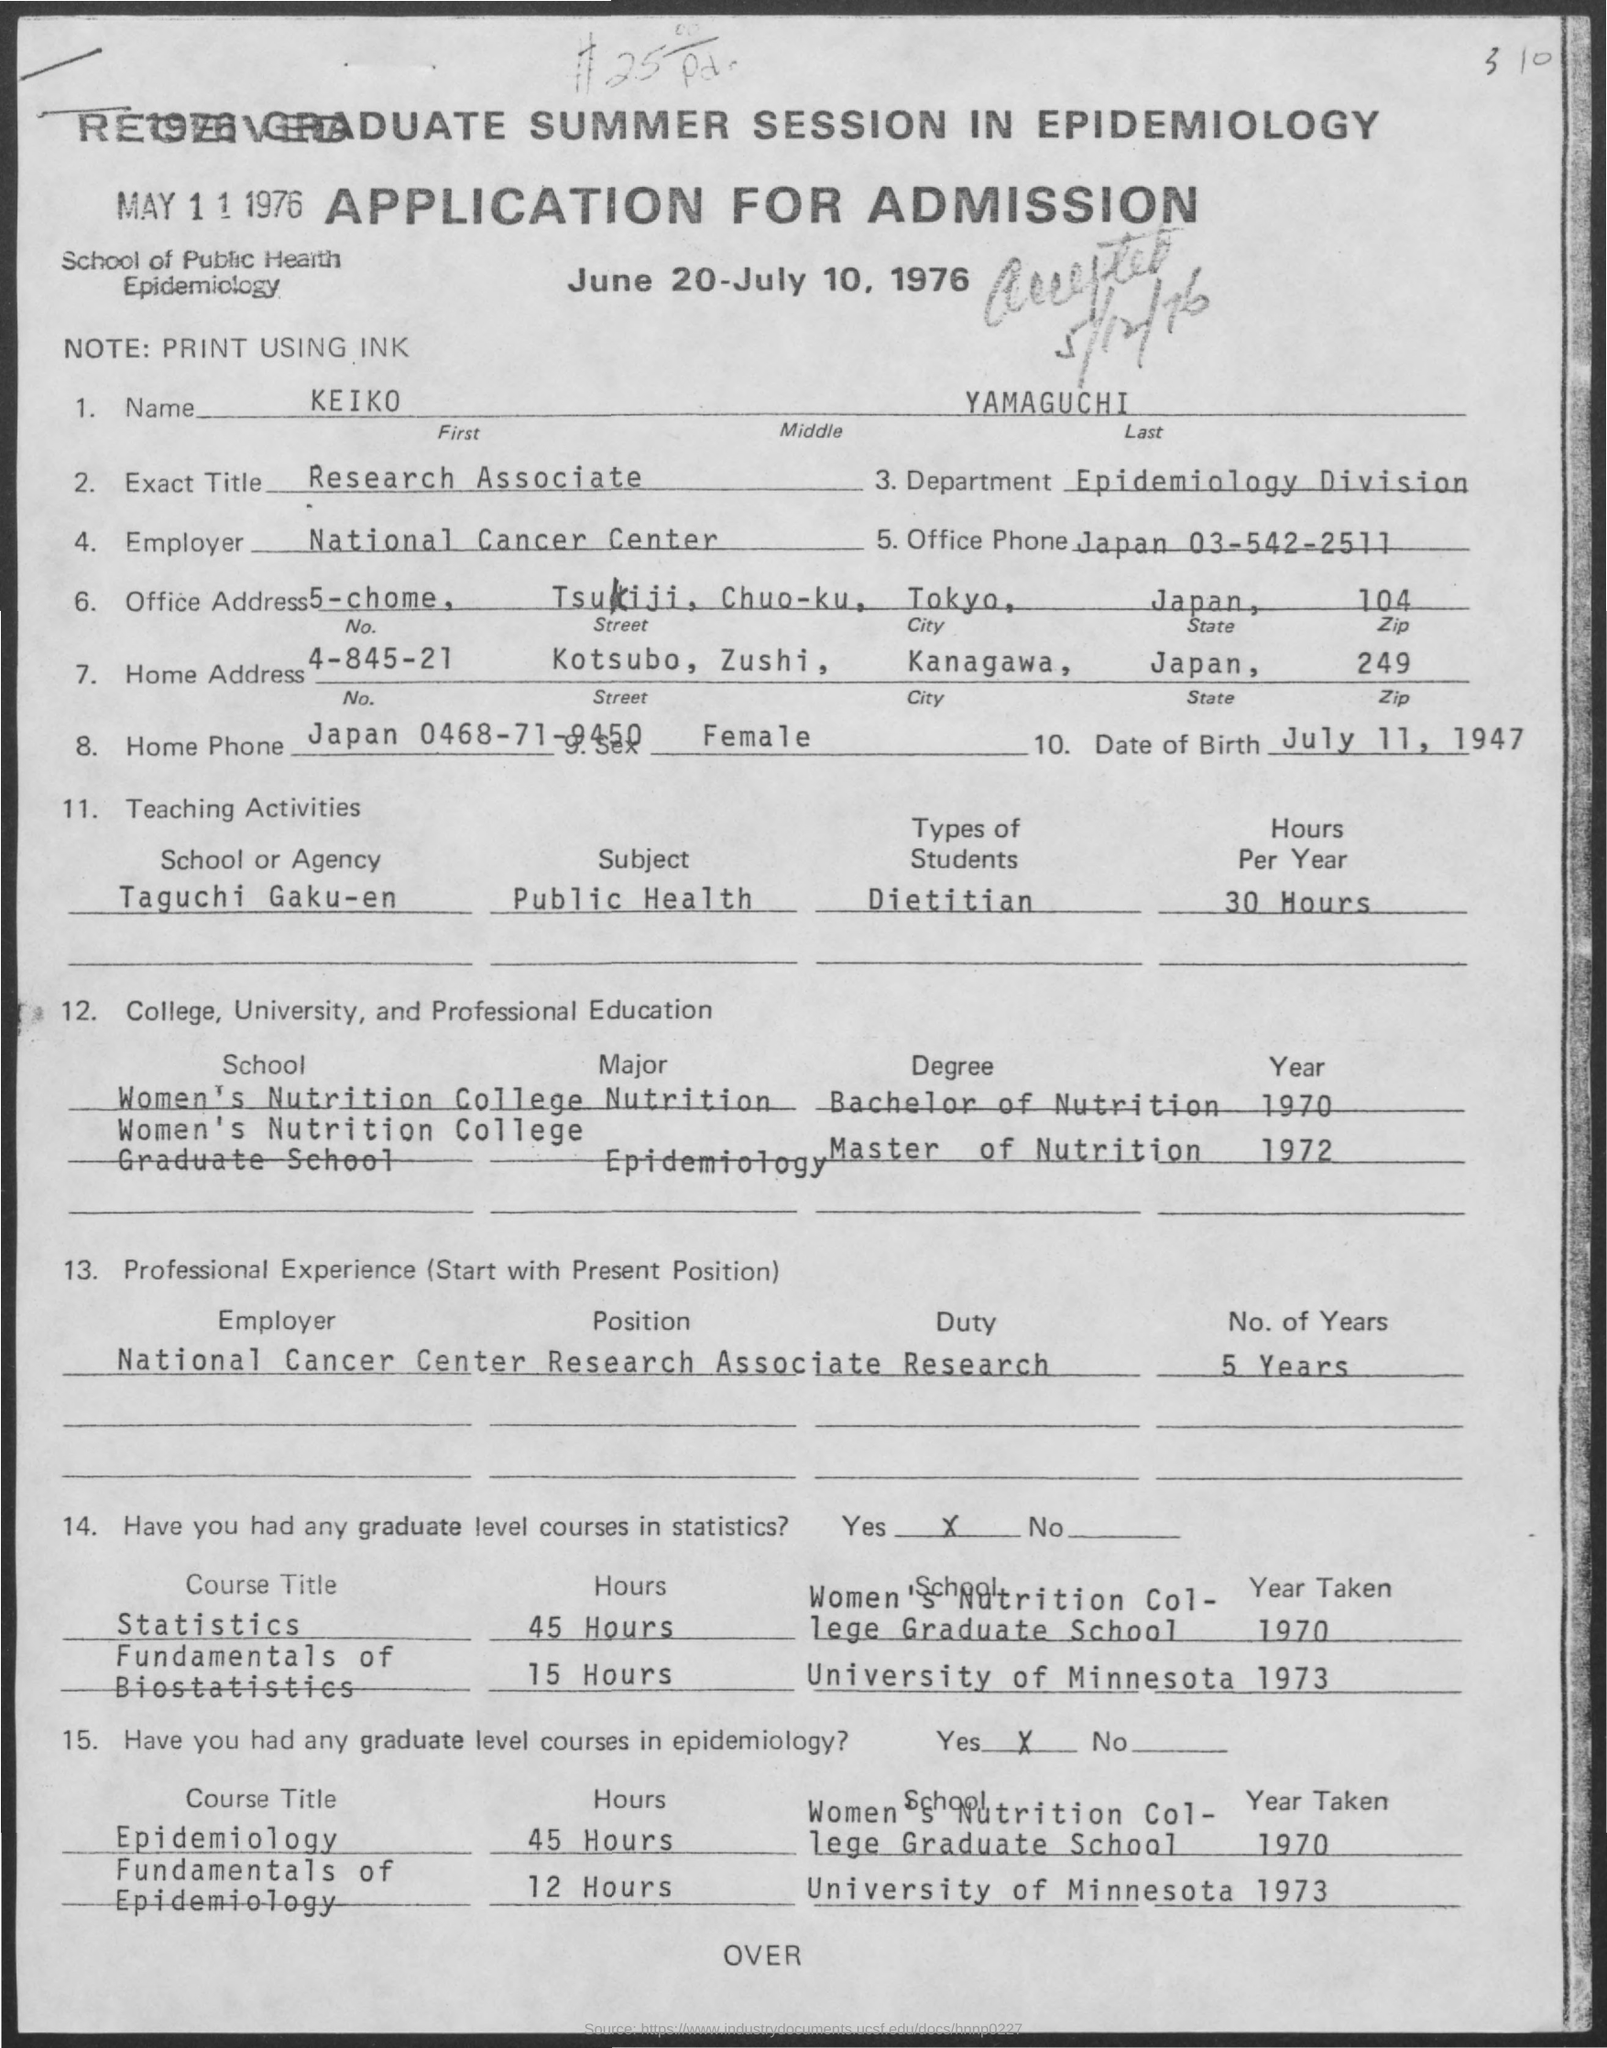What is the First Name?
Your answer should be very brief. Keiko. What is the Last Name?
Offer a terse response. Yamaguchi. What is the Exact Title?
Give a very brief answer. Research Associate. What is the Department?
Make the answer very short. Epidemiology division. Who is the Employer?
Ensure brevity in your answer.  National cancer center. What is the Sex?
Keep it short and to the point. Female. What is the Date of Birth?
Offer a terse response. July 11, 1947. When was the Application Received?
Keep it short and to the point. May 11 1976. 